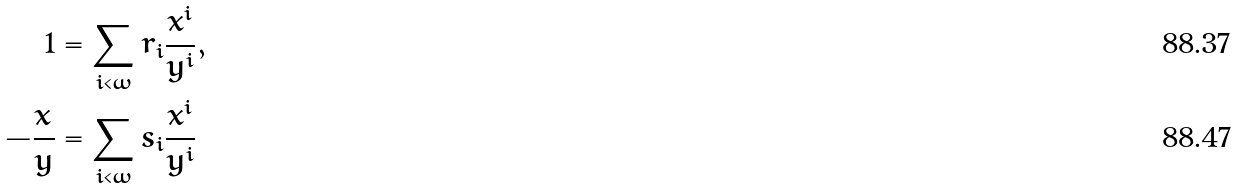<formula> <loc_0><loc_0><loc_500><loc_500>1 & = \sum _ { i < \omega } r _ { i } \frac { x ^ { i } } { y ^ { i } } , \\ - \frac { x } { y } & = \sum _ { i < \omega } s _ { i } \frac { x ^ { i } } { y ^ { i } }</formula> 